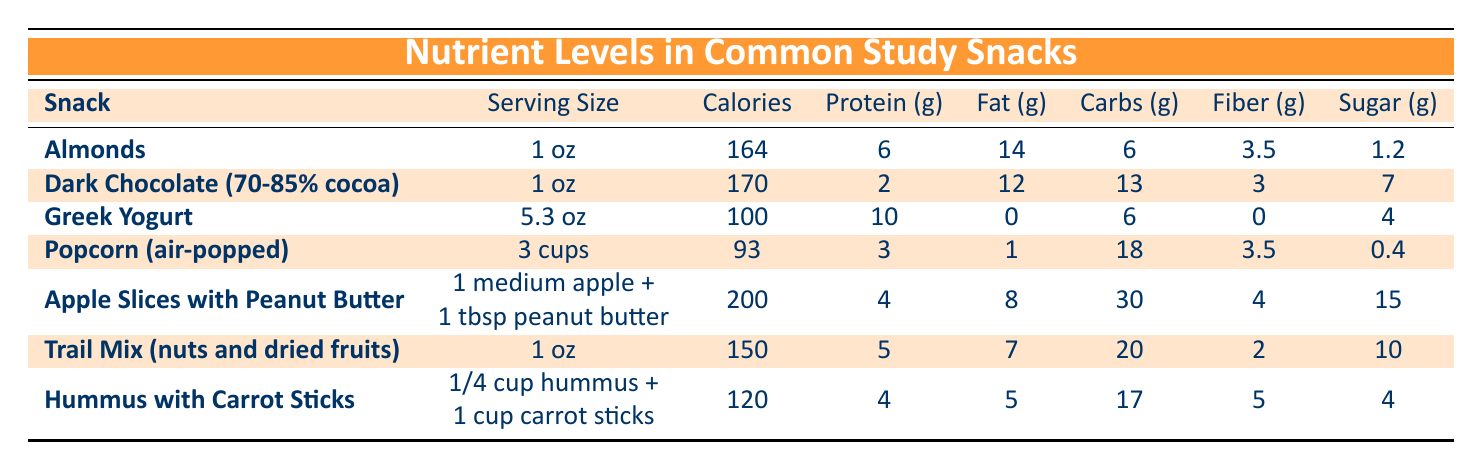What is the serving size of Dark Chocolate? The table provides the serving size directly next to the snack name for Dark Chocolate, which is listed as "1 oz."
Answer: 1 oz Which snack has the highest fat content per serving? By reviewing the fat content column, Almonds have 14g of fat, which is higher than any other snack listed.
Answer: Almonds What is the total amount of protein in Apple Slices with Peanut Butter and Hummus with Carrot Sticks? The protein content of Apple Slices with Peanut Butter is 4g, and for Hummus with Carrot Sticks, it is also 4g. Adding these together gives 4 + 4 = 8g.
Answer: 8g Is the sugar content in Greek Yogurt greater than in Popcorn? The sugar content for Greek Yogurt is 4g, while for Popcorn, it is 0.4g. Since 4g is greater than 0.4g, the statement is true.
Answer: Yes What is the average calorie content of all snacks listed? The calorie contents are: Almonds (164), Dark Chocolate (170), Greek Yogurt (100), Popcorn (93), Apple Slices (200), Trail Mix (150), Hummus (120). Summing these gives 164 + 170 + 100 + 93 + 200 + 150 + 120 = 1097. There are 7 snacks, so dividing gives 1097 / 7 = 156.71. Rounding to two decimal places gives 156.71.
Answer: 156.71 